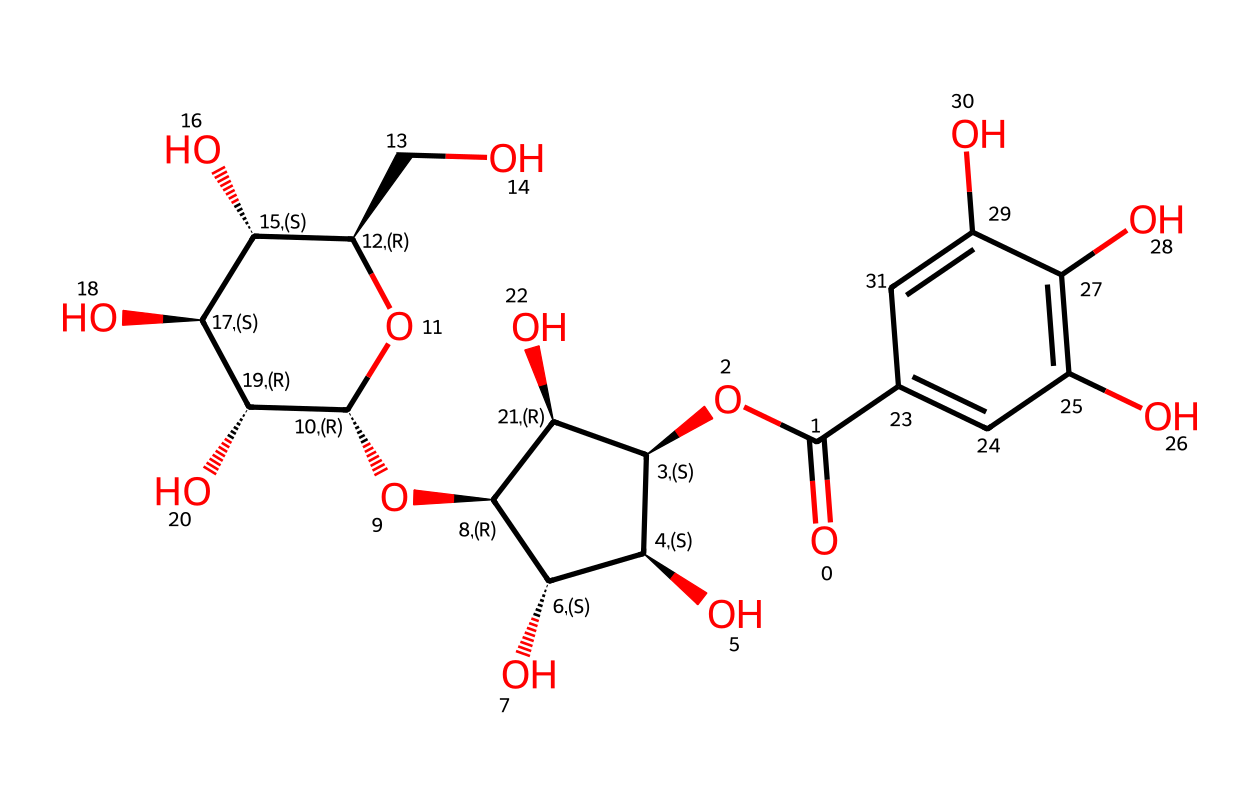what is the primary functional group present in this chemical? The chemical has a carboxylic acid functional group, indicated by the -COOH structure visible at one end of the molecular structure.
Answer: carboxylic acid how many hydroxyl groups are present in this molecule? Upon examining the structure, there are a total of four hydroxyl (-OH) groups due to the multiple -OH attachments indicated in the structure.
Answer: four what type of acid is classified here? Given the presence of multiple hydroxyl groups and a carboxylic acid, this aligns with polyphenolic acids, specifically tannic acid.
Answer: tannic acid what is the significance of tannic acid in leather preservation? Tannic acid helps in the tanning process which significantly enhances the durability and resistance of leather, contributing to the preservation of military equipment during conflicts.
Answer: preservation how many rings are indicated in the chemical structure? The chemical shows two distinct cyclic structures, or rings, which are typical in polyphenolic compounds, characteristic of tannic acid.
Answer: two which part of the structure enhances its binding with leather fibers? The carboxylic acid group, through its ability to form hydrogen bonds and coordinate with protein structures in leather, enhances compatibility and binding.
Answer: carboxylic acid group 